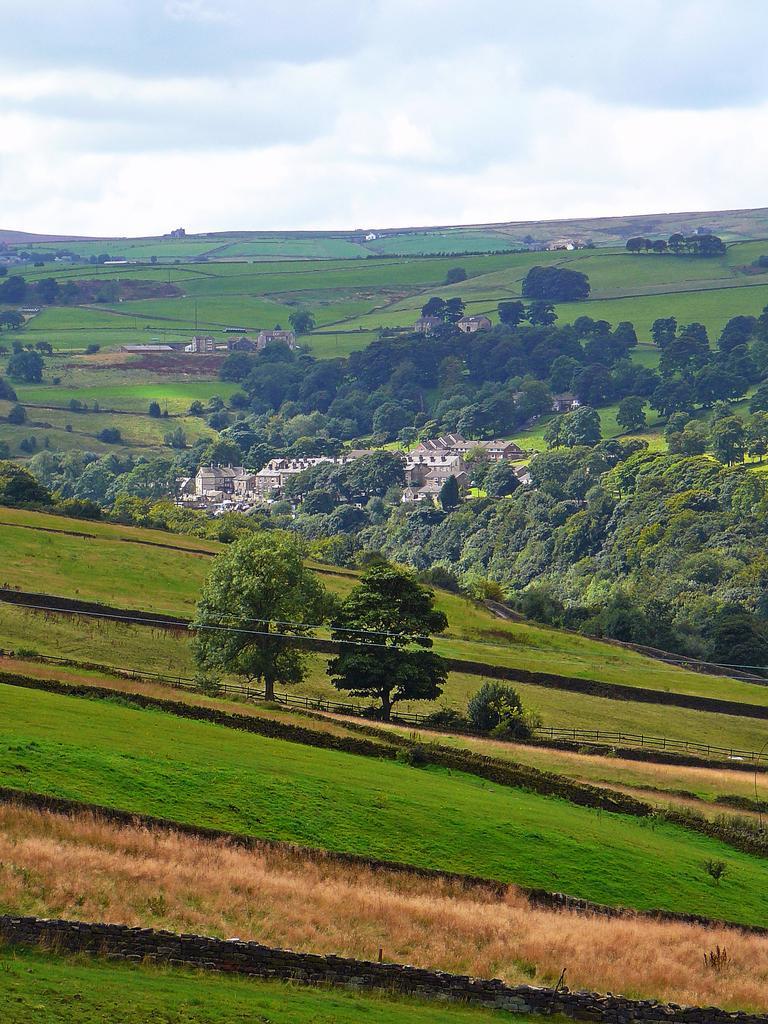In one or two sentences, can you explain what this image depicts? In this image I can see grass, trees, houses, farms and the sky. This image is taken may be in the farm during a day. 